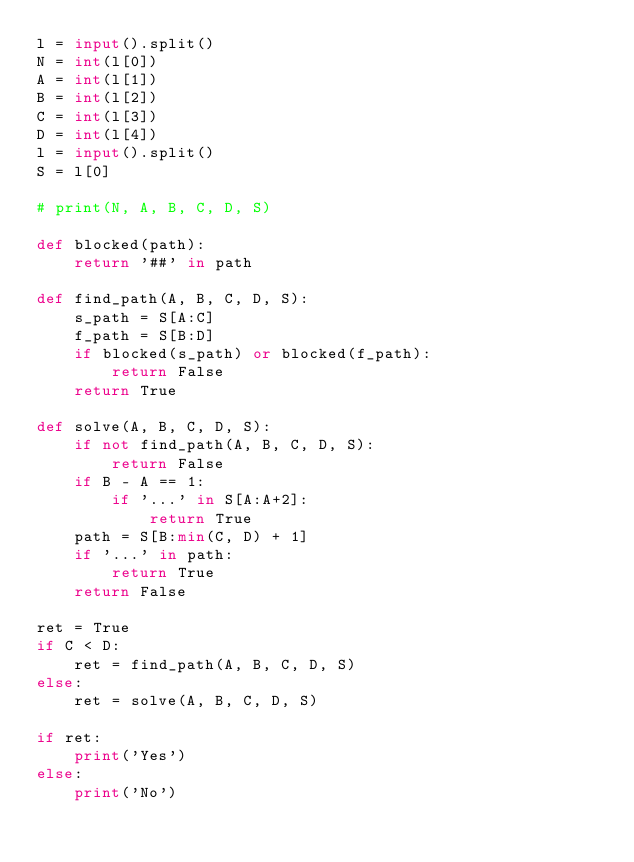Convert code to text. <code><loc_0><loc_0><loc_500><loc_500><_Python_>l = input().split()
N = int(l[0])
A = int(l[1])
B = int(l[2])
C = int(l[3])
D = int(l[4])
l = input().split()
S = l[0]

# print(N, A, B, C, D, S)

def blocked(path):
    return '##' in path

def find_path(A, B, C, D, S):
    s_path = S[A:C]
    f_path = S[B:D]
    if blocked(s_path) or blocked(f_path):
        return False
    return True

def solve(A, B, C, D, S):
    if not find_path(A, B, C, D, S):
        return False
    if B - A == 1:
        if '...' in S[A:A+2]:
            return True
    path = S[B:min(C, D) + 1]
    if '...' in path:
        return True
    return False

ret = True
if C < D:
    ret = find_path(A, B, C, D, S)
else:
    ret = solve(A, B, C, D, S)

if ret:
    print('Yes')
else:
    print('No')
</code> 